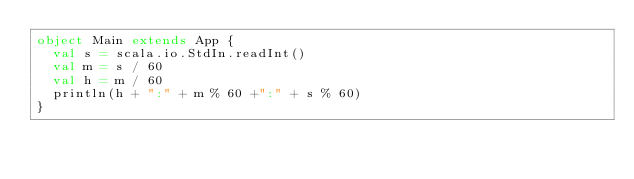Convert code to text. <code><loc_0><loc_0><loc_500><loc_500><_Scala_>object Main extends App {
  val s = scala.io.StdIn.readInt()
  val m = s / 60
  val h = m / 60
  println(h + ":" + m % 60 +":" + s % 60)
}

</code> 